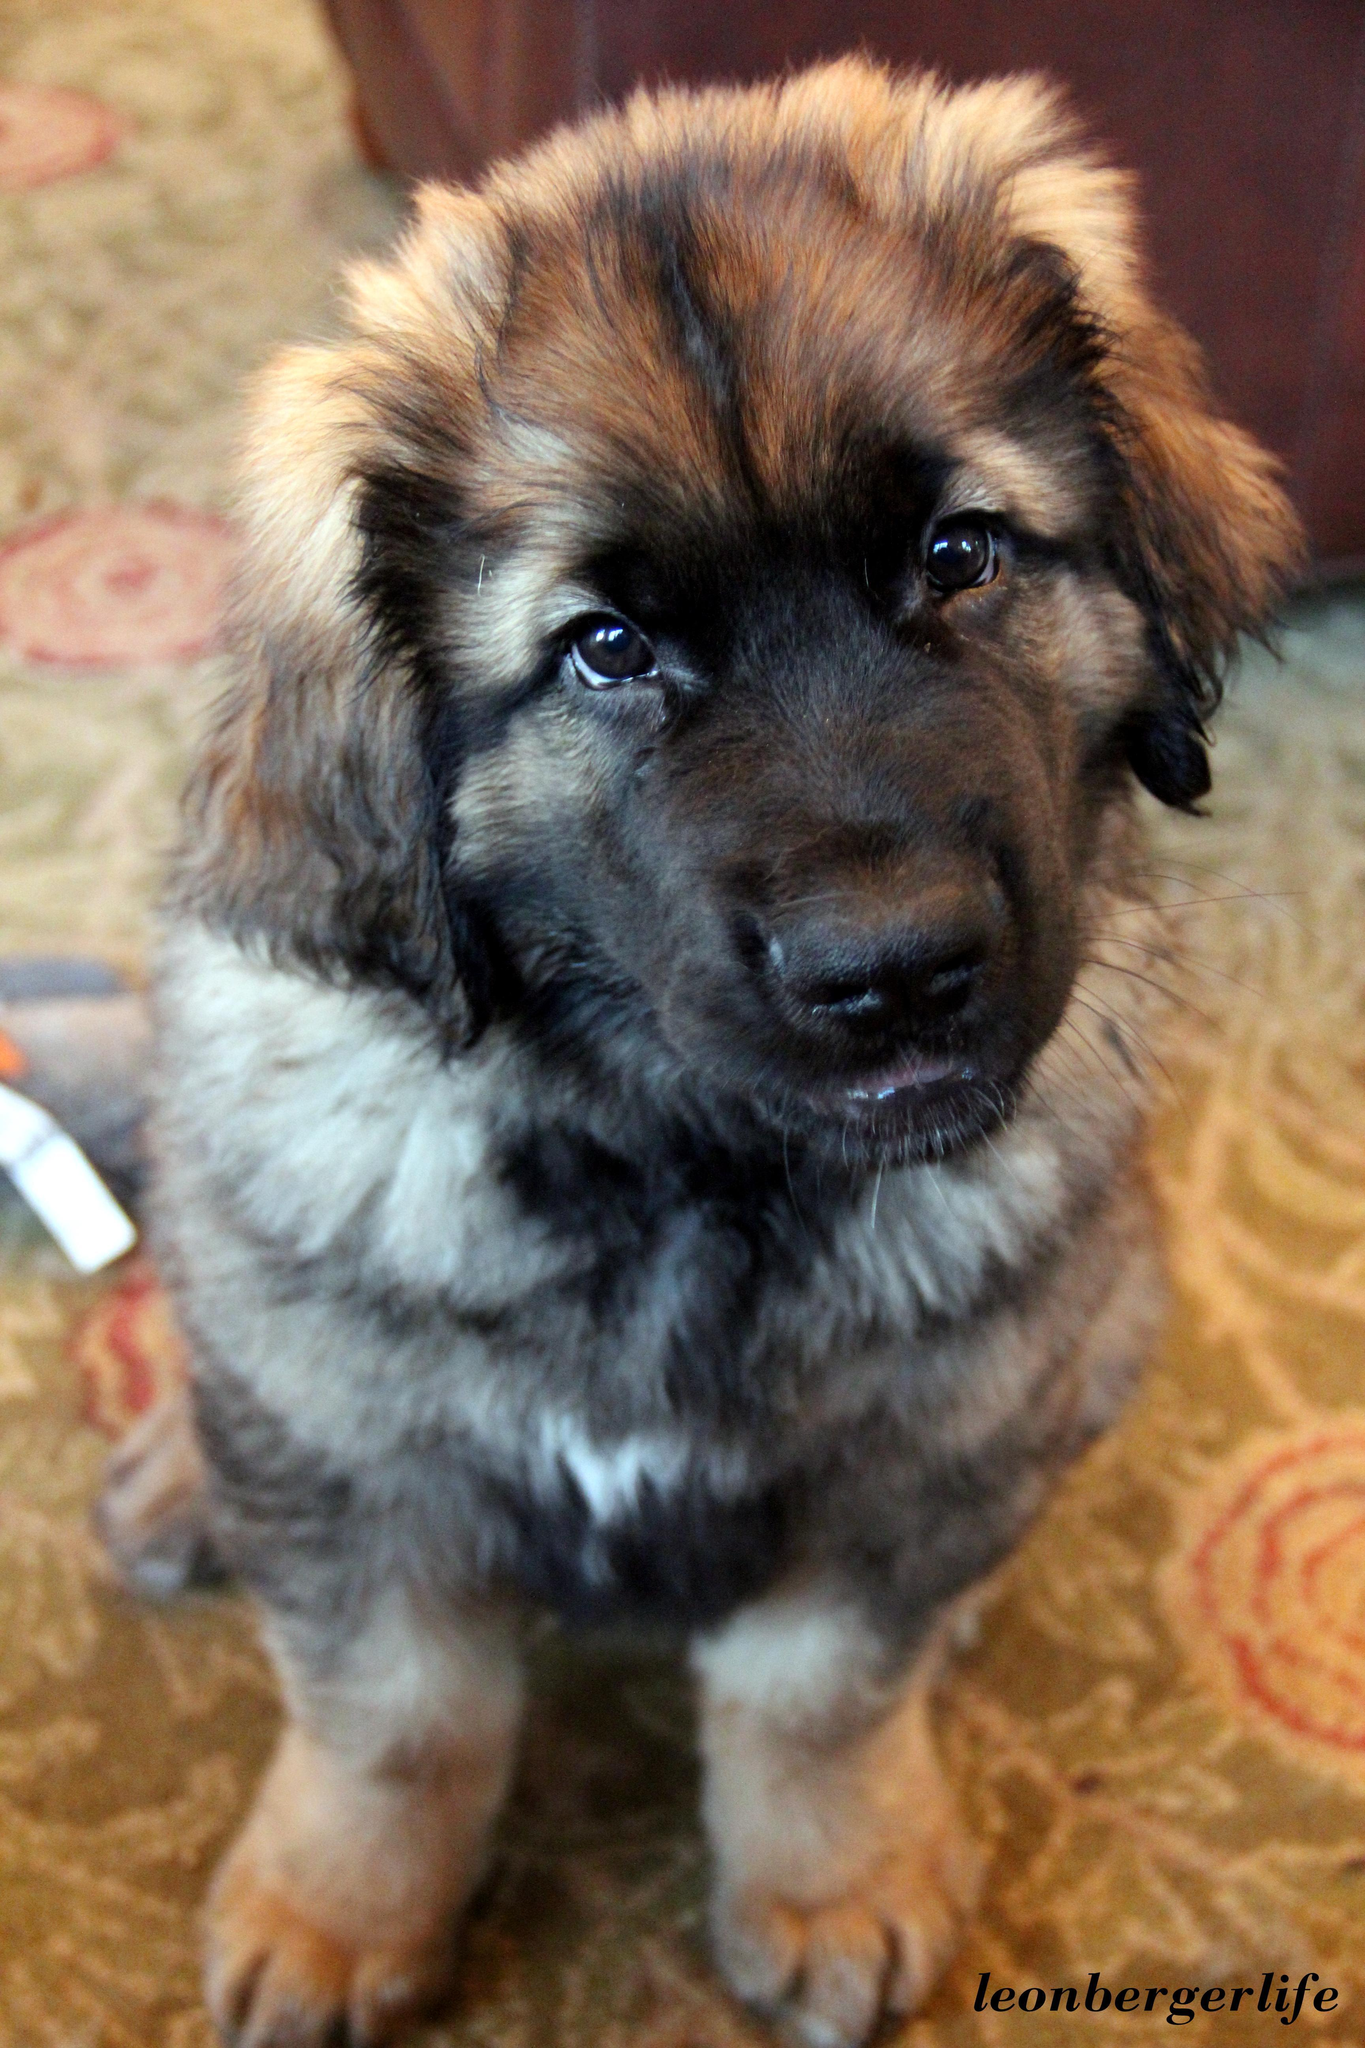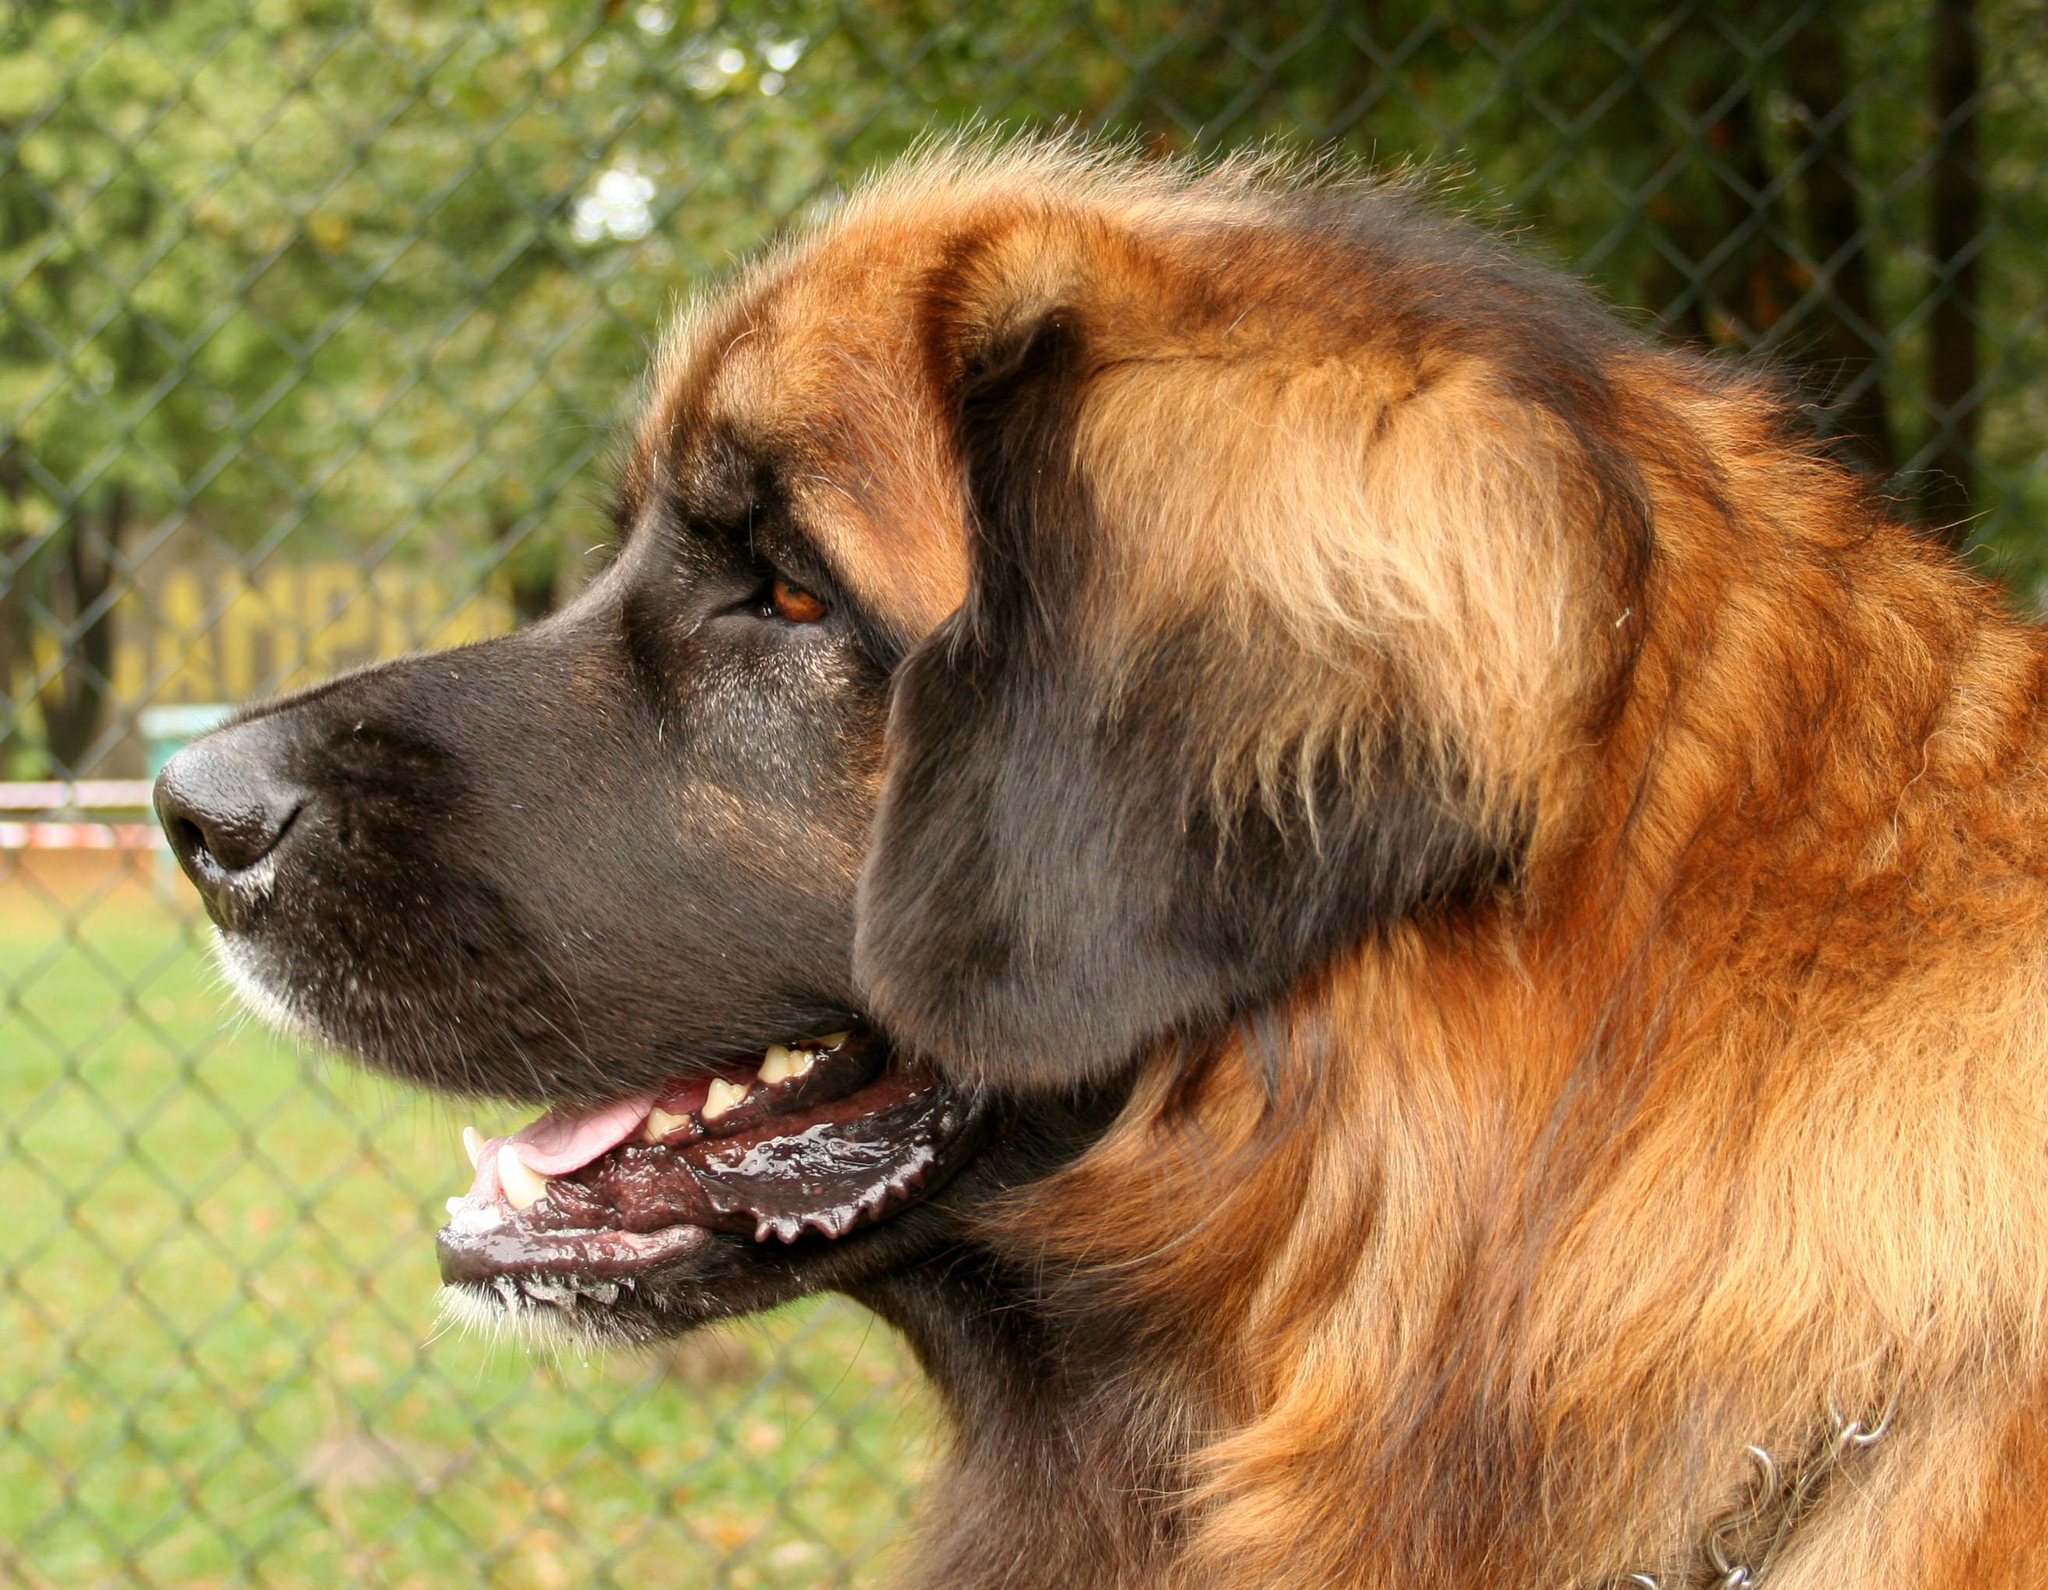The first image is the image on the left, the second image is the image on the right. For the images displayed, is the sentence "None of the dogs are alone and at least one of the dogs has a dark colored face." factually correct? Answer yes or no. No. The first image is the image on the left, the second image is the image on the right. Examine the images to the left and right. Is the description "A group of dogs is in the grass in at least one picture." accurate? Answer yes or no. No. 